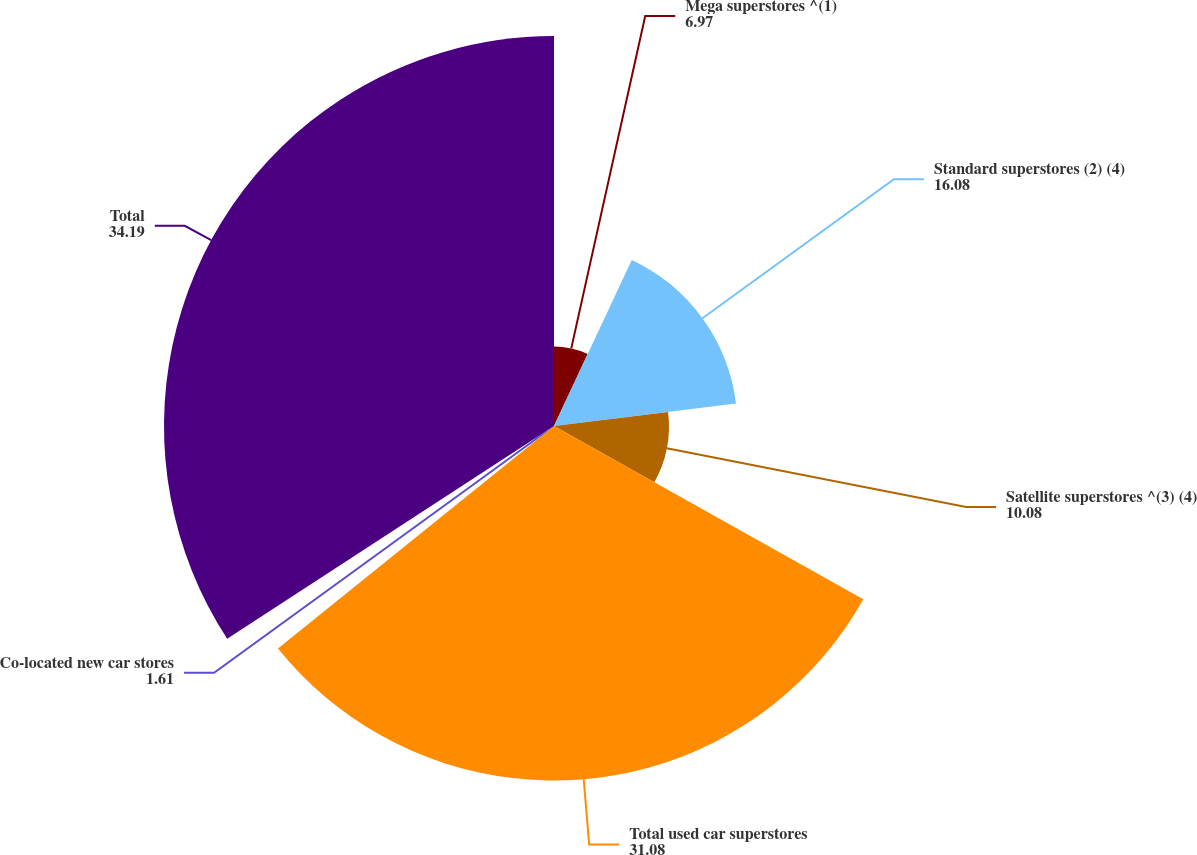Convert chart to OTSL. <chart><loc_0><loc_0><loc_500><loc_500><pie_chart><fcel>Mega superstores ^(1)<fcel>Standard superstores (2) (4)<fcel>Satellite superstores ^(3) (4)<fcel>Total used car superstores<fcel>Co-located new car stores<fcel>Total<nl><fcel>6.97%<fcel>16.08%<fcel>10.08%<fcel>31.08%<fcel>1.61%<fcel>34.19%<nl></chart> 